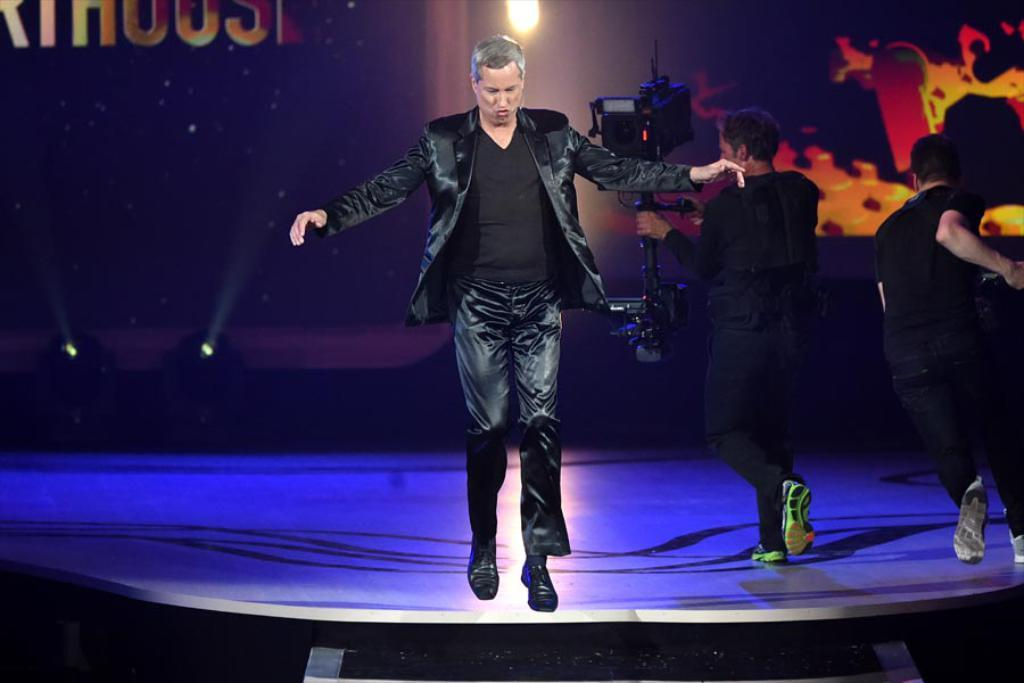What is the man in the image doing? There is a man jumping in the image. What is the other man in the image doing? There is a man holding a camera and walking in the image. What is the third man in the image doing? There is another man running in the image. What letter is the man holding in the image? There is no man holding a letter in the image. Is there a crib present at the party in the image? There is no party or crib present in the image. 